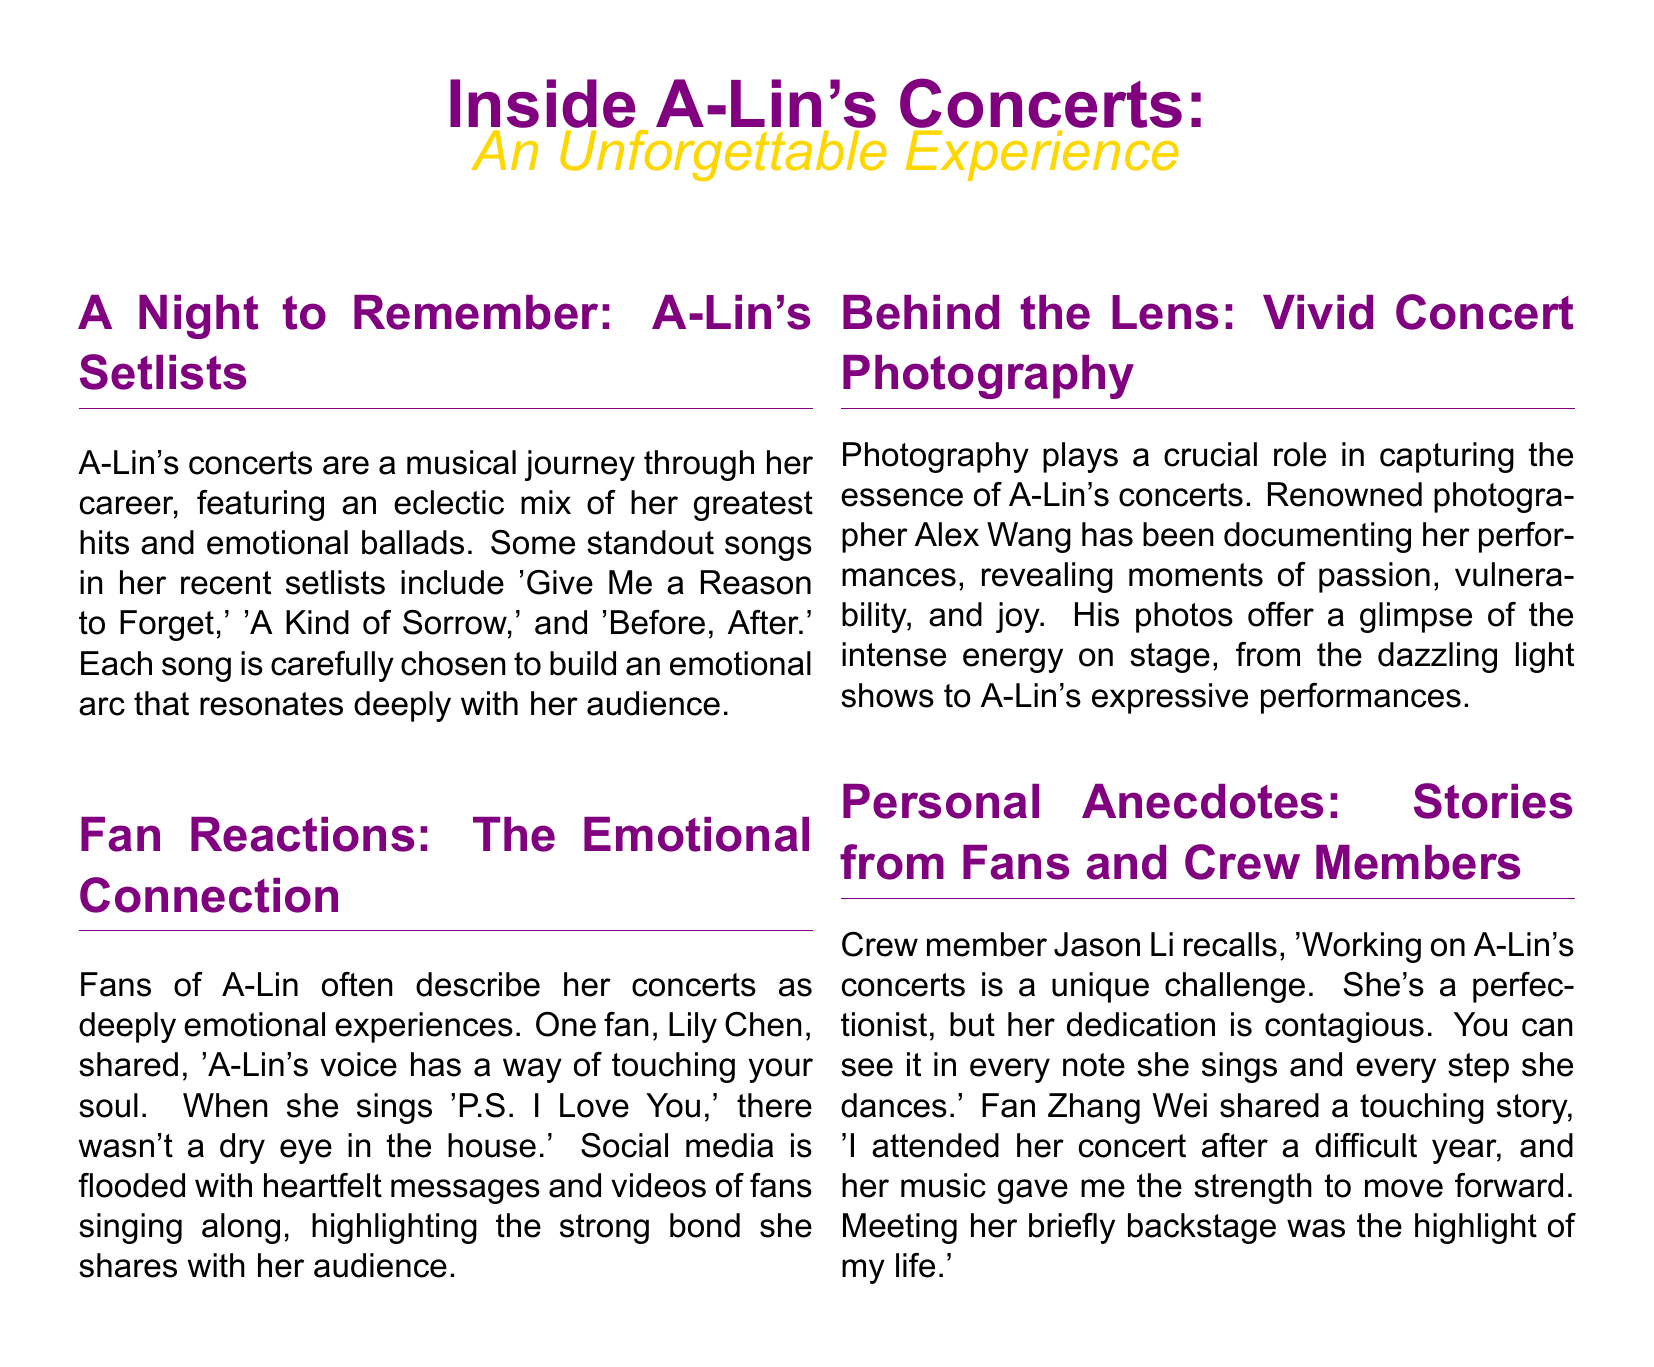what is the title of A-Lin's concerts feature? The title of the feature is prominently displayed at the top of the document.
Answer: Inside A-Lin's Concerts: An Unforgettable Experience who is the photographer mentioned in the document? The photographer who has been documenting A-Lin's performances is named in the document.
Answer: Alex Wang name one song from A-Lin's setlist. The document lists standout songs from A-Lin's setlists.
Answer: Give Me a Reason to Forget who shared an emotional experience from a concert in the document? The document includes a quote from a fan discussing their emotional reaction to A-Lin's performance.
Answer: Lily Chen what is a personal anecdote shared by a crew member? The document includes a quote from a crew member discussing A-Lin's work ethic.
Answer: She's a perfectionist, but her dedication is contagious how is A-Lin's voice described by fans? Fans' sentiments about A-Lin's voice are captured in the document.
Answer: Touching your soul how does the document describe the overall experience of A-Lin's concerts? The document discusses the emotional impact of A-Lin's concerts on her audience.
Answer: Deeply emotional experiences which song is mentioned as making fans cry during performances? The document highlights a specific song that had a profound emotional effect on the audience.
Answer: P.S. I Love You 